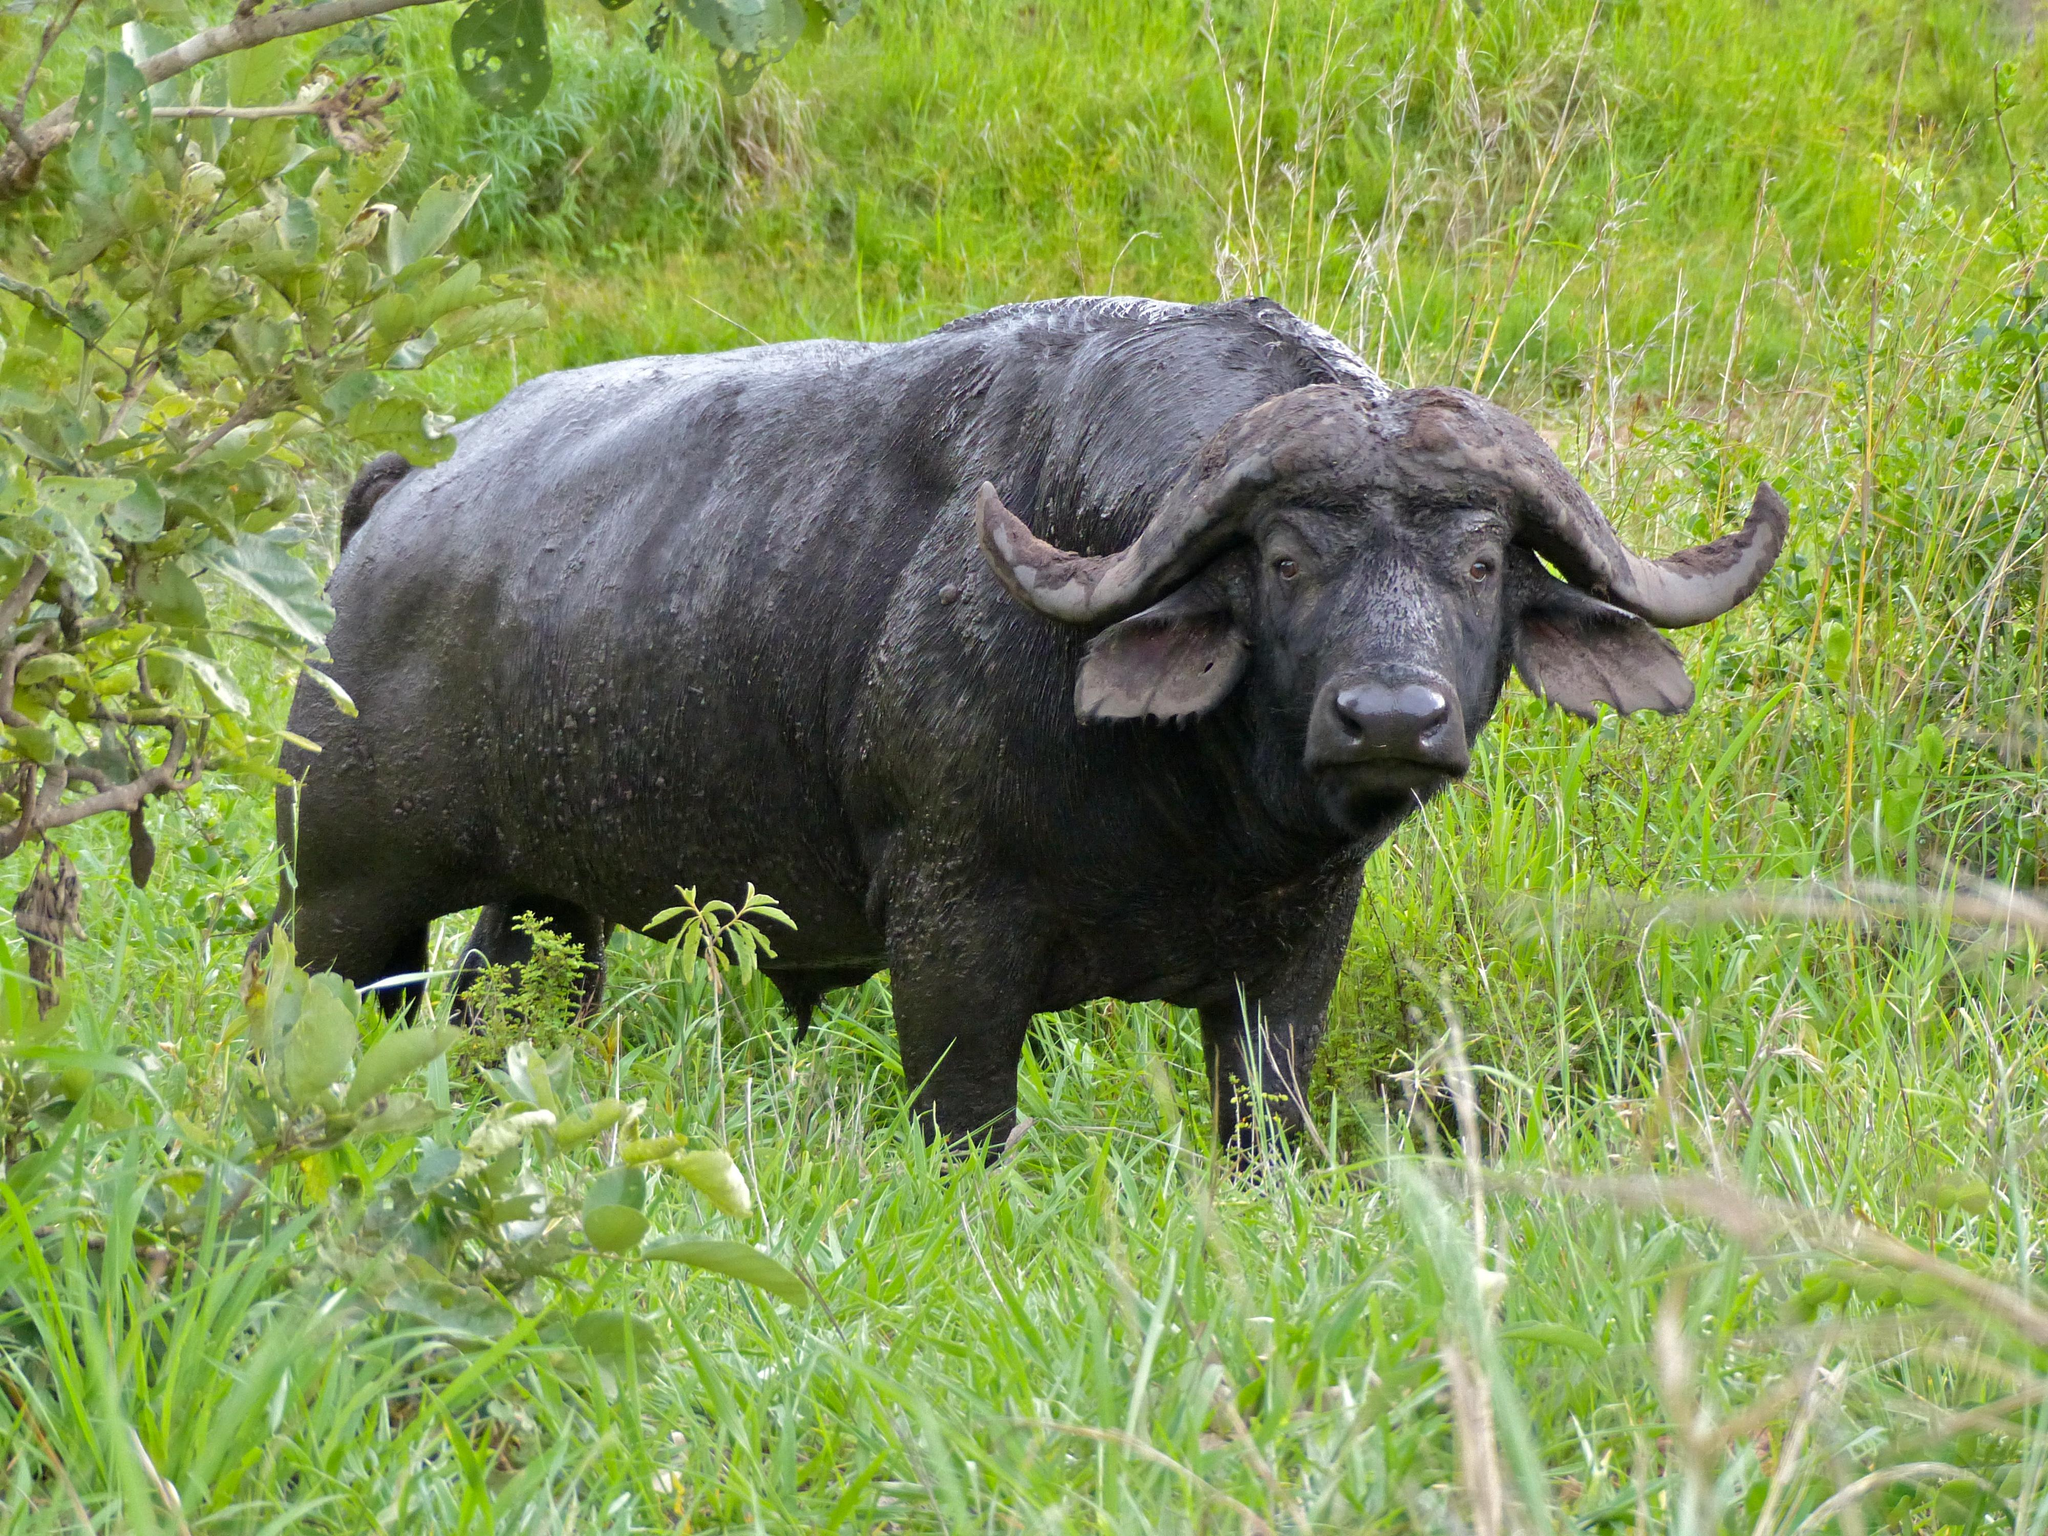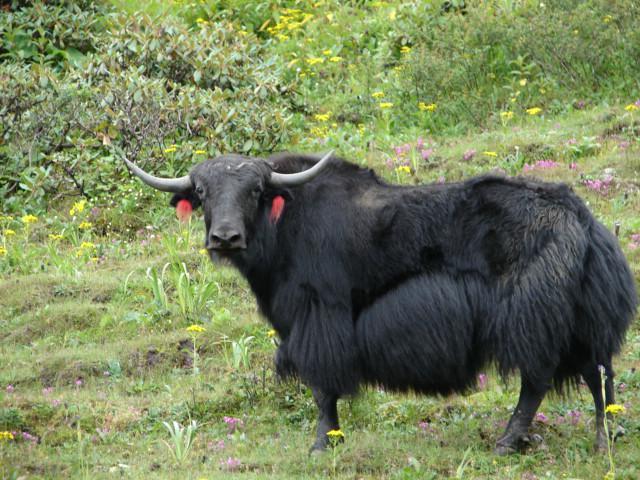The first image is the image on the left, the second image is the image on the right. Given the left and right images, does the statement "The water buffalo in the right image is facing towards the right." hold true? Answer yes or no. No. The first image is the image on the left, the second image is the image on the right. Given the left and right images, does the statement "The bulls in the image on the left are standing facing toward the left." hold true? Answer yes or no. No. 